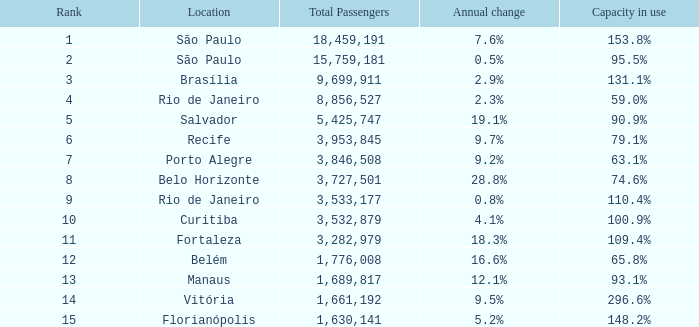What is the aggregate of passengers when the annual variation is None. 